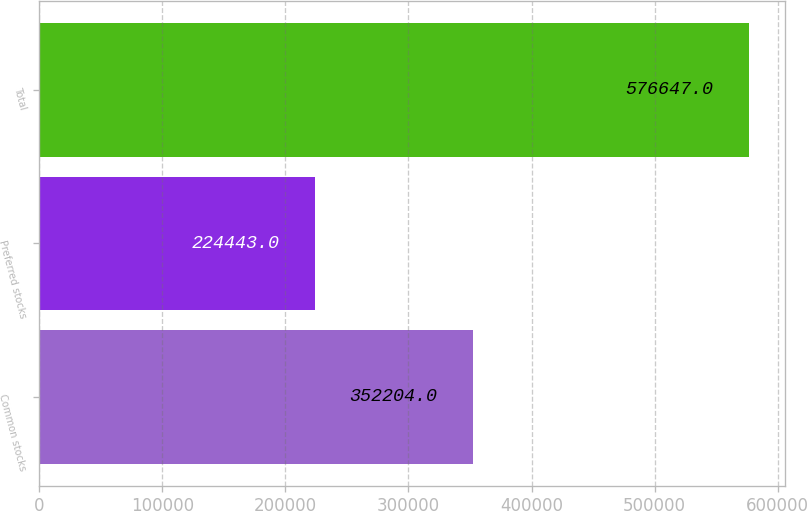<chart> <loc_0><loc_0><loc_500><loc_500><bar_chart><fcel>Common stocks<fcel>Preferred stocks<fcel>Total<nl><fcel>352204<fcel>224443<fcel>576647<nl></chart> 